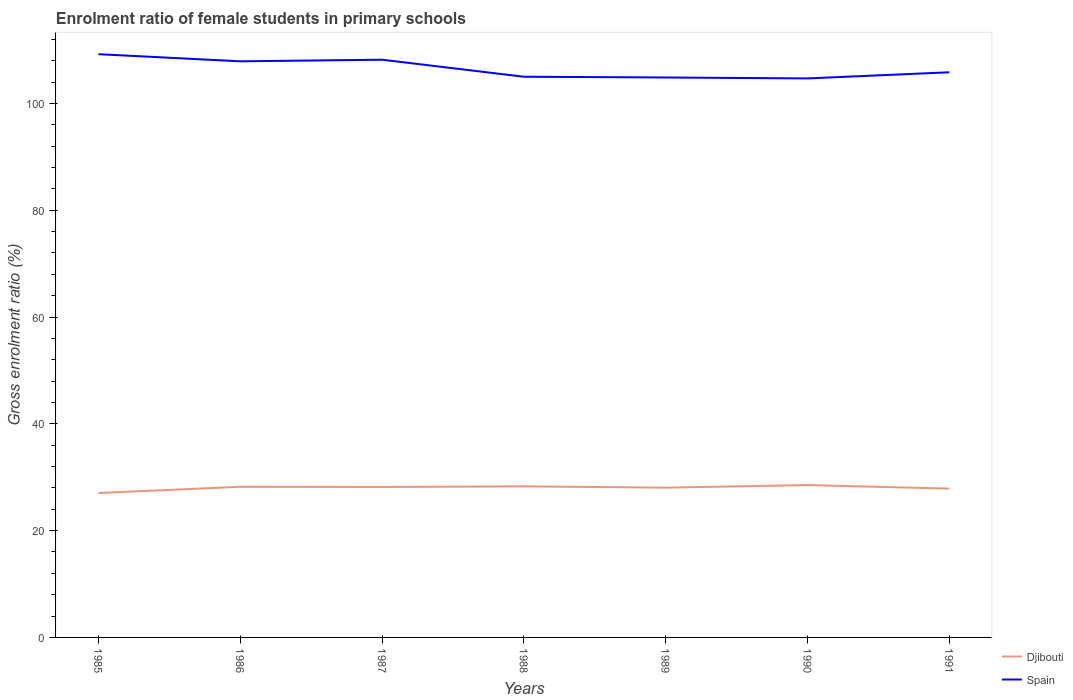How many different coloured lines are there?
Provide a succinct answer. 2. Does the line corresponding to Djibouti intersect with the line corresponding to Spain?
Your response must be concise. No. Across all years, what is the maximum enrolment ratio of female students in primary schools in Djibouti?
Make the answer very short. 27.05. What is the total enrolment ratio of female students in primary schools in Djibouti in the graph?
Your response must be concise. 0.16. What is the difference between the highest and the second highest enrolment ratio of female students in primary schools in Spain?
Ensure brevity in your answer.  4.54. What is the difference between two consecutive major ticks on the Y-axis?
Your answer should be compact. 20. How many legend labels are there?
Provide a short and direct response. 2. What is the title of the graph?
Your answer should be very brief. Enrolment ratio of female students in primary schools. Does "San Marino" appear as one of the legend labels in the graph?
Your answer should be compact. No. What is the label or title of the Y-axis?
Keep it short and to the point. Gross enrolment ratio (%). What is the Gross enrolment ratio (%) of Djibouti in 1985?
Ensure brevity in your answer.  27.05. What is the Gross enrolment ratio (%) in Spain in 1985?
Your answer should be very brief. 109.23. What is the Gross enrolment ratio (%) in Djibouti in 1986?
Make the answer very short. 28.21. What is the Gross enrolment ratio (%) in Spain in 1986?
Offer a terse response. 107.89. What is the Gross enrolment ratio (%) of Djibouti in 1987?
Give a very brief answer. 28.18. What is the Gross enrolment ratio (%) in Spain in 1987?
Offer a very short reply. 108.19. What is the Gross enrolment ratio (%) in Djibouti in 1988?
Provide a short and direct response. 28.3. What is the Gross enrolment ratio (%) in Spain in 1988?
Your response must be concise. 105. What is the Gross enrolment ratio (%) of Djibouti in 1989?
Make the answer very short. 28.05. What is the Gross enrolment ratio (%) in Spain in 1989?
Your response must be concise. 104.86. What is the Gross enrolment ratio (%) in Djibouti in 1990?
Your response must be concise. 28.54. What is the Gross enrolment ratio (%) of Spain in 1990?
Offer a very short reply. 104.69. What is the Gross enrolment ratio (%) in Djibouti in 1991?
Your response must be concise. 27.87. What is the Gross enrolment ratio (%) in Spain in 1991?
Your response must be concise. 105.84. Across all years, what is the maximum Gross enrolment ratio (%) in Djibouti?
Provide a short and direct response. 28.54. Across all years, what is the maximum Gross enrolment ratio (%) in Spain?
Make the answer very short. 109.23. Across all years, what is the minimum Gross enrolment ratio (%) of Djibouti?
Your answer should be compact. 27.05. Across all years, what is the minimum Gross enrolment ratio (%) of Spain?
Provide a succinct answer. 104.69. What is the total Gross enrolment ratio (%) of Djibouti in the graph?
Offer a terse response. 196.19. What is the total Gross enrolment ratio (%) of Spain in the graph?
Make the answer very short. 745.7. What is the difference between the Gross enrolment ratio (%) in Djibouti in 1985 and that in 1986?
Offer a very short reply. -1.16. What is the difference between the Gross enrolment ratio (%) in Spain in 1985 and that in 1986?
Your response must be concise. 1.33. What is the difference between the Gross enrolment ratio (%) in Djibouti in 1985 and that in 1987?
Offer a very short reply. -1.13. What is the difference between the Gross enrolment ratio (%) in Spain in 1985 and that in 1987?
Offer a terse response. 1.03. What is the difference between the Gross enrolment ratio (%) of Djibouti in 1985 and that in 1988?
Keep it short and to the point. -1.25. What is the difference between the Gross enrolment ratio (%) in Spain in 1985 and that in 1988?
Make the answer very short. 4.22. What is the difference between the Gross enrolment ratio (%) of Djibouti in 1985 and that in 1989?
Keep it short and to the point. -1. What is the difference between the Gross enrolment ratio (%) in Spain in 1985 and that in 1989?
Provide a short and direct response. 4.36. What is the difference between the Gross enrolment ratio (%) of Djibouti in 1985 and that in 1990?
Provide a succinct answer. -1.49. What is the difference between the Gross enrolment ratio (%) of Spain in 1985 and that in 1990?
Give a very brief answer. 4.54. What is the difference between the Gross enrolment ratio (%) in Djibouti in 1985 and that in 1991?
Give a very brief answer. -0.82. What is the difference between the Gross enrolment ratio (%) of Spain in 1985 and that in 1991?
Offer a very short reply. 3.39. What is the difference between the Gross enrolment ratio (%) in Djibouti in 1986 and that in 1987?
Your answer should be compact. 0.03. What is the difference between the Gross enrolment ratio (%) in Spain in 1986 and that in 1987?
Offer a terse response. -0.3. What is the difference between the Gross enrolment ratio (%) in Djibouti in 1986 and that in 1988?
Your answer should be very brief. -0.09. What is the difference between the Gross enrolment ratio (%) of Spain in 1986 and that in 1988?
Make the answer very short. 2.89. What is the difference between the Gross enrolment ratio (%) of Djibouti in 1986 and that in 1989?
Give a very brief answer. 0.16. What is the difference between the Gross enrolment ratio (%) of Spain in 1986 and that in 1989?
Your answer should be very brief. 3.03. What is the difference between the Gross enrolment ratio (%) of Djibouti in 1986 and that in 1990?
Keep it short and to the point. -0.33. What is the difference between the Gross enrolment ratio (%) in Spain in 1986 and that in 1990?
Your answer should be compact. 3.2. What is the difference between the Gross enrolment ratio (%) in Djibouti in 1986 and that in 1991?
Ensure brevity in your answer.  0.34. What is the difference between the Gross enrolment ratio (%) in Spain in 1986 and that in 1991?
Give a very brief answer. 2.05. What is the difference between the Gross enrolment ratio (%) of Djibouti in 1987 and that in 1988?
Ensure brevity in your answer.  -0.12. What is the difference between the Gross enrolment ratio (%) in Spain in 1987 and that in 1988?
Your answer should be compact. 3.19. What is the difference between the Gross enrolment ratio (%) of Djibouti in 1987 and that in 1989?
Ensure brevity in your answer.  0.13. What is the difference between the Gross enrolment ratio (%) of Spain in 1987 and that in 1989?
Offer a terse response. 3.33. What is the difference between the Gross enrolment ratio (%) of Djibouti in 1987 and that in 1990?
Your answer should be very brief. -0.36. What is the difference between the Gross enrolment ratio (%) of Spain in 1987 and that in 1990?
Ensure brevity in your answer.  3.51. What is the difference between the Gross enrolment ratio (%) in Djibouti in 1987 and that in 1991?
Keep it short and to the point. 0.31. What is the difference between the Gross enrolment ratio (%) in Spain in 1987 and that in 1991?
Make the answer very short. 2.36. What is the difference between the Gross enrolment ratio (%) in Djibouti in 1988 and that in 1989?
Ensure brevity in your answer.  0.25. What is the difference between the Gross enrolment ratio (%) of Spain in 1988 and that in 1989?
Provide a short and direct response. 0.14. What is the difference between the Gross enrolment ratio (%) of Djibouti in 1988 and that in 1990?
Ensure brevity in your answer.  -0.24. What is the difference between the Gross enrolment ratio (%) in Spain in 1988 and that in 1990?
Give a very brief answer. 0.32. What is the difference between the Gross enrolment ratio (%) in Djibouti in 1988 and that in 1991?
Provide a succinct answer. 0.42. What is the difference between the Gross enrolment ratio (%) in Spain in 1988 and that in 1991?
Your answer should be very brief. -0.84. What is the difference between the Gross enrolment ratio (%) of Djibouti in 1989 and that in 1990?
Ensure brevity in your answer.  -0.49. What is the difference between the Gross enrolment ratio (%) in Spain in 1989 and that in 1990?
Ensure brevity in your answer.  0.18. What is the difference between the Gross enrolment ratio (%) in Djibouti in 1989 and that in 1991?
Keep it short and to the point. 0.18. What is the difference between the Gross enrolment ratio (%) in Spain in 1989 and that in 1991?
Ensure brevity in your answer.  -0.98. What is the difference between the Gross enrolment ratio (%) of Djibouti in 1990 and that in 1991?
Make the answer very short. 0.66. What is the difference between the Gross enrolment ratio (%) in Spain in 1990 and that in 1991?
Your response must be concise. -1.15. What is the difference between the Gross enrolment ratio (%) of Djibouti in 1985 and the Gross enrolment ratio (%) of Spain in 1986?
Give a very brief answer. -80.84. What is the difference between the Gross enrolment ratio (%) in Djibouti in 1985 and the Gross enrolment ratio (%) in Spain in 1987?
Offer a very short reply. -81.15. What is the difference between the Gross enrolment ratio (%) in Djibouti in 1985 and the Gross enrolment ratio (%) in Spain in 1988?
Provide a short and direct response. -77.96. What is the difference between the Gross enrolment ratio (%) of Djibouti in 1985 and the Gross enrolment ratio (%) of Spain in 1989?
Your answer should be very brief. -77.81. What is the difference between the Gross enrolment ratio (%) in Djibouti in 1985 and the Gross enrolment ratio (%) in Spain in 1990?
Ensure brevity in your answer.  -77.64. What is the difference between the Gross enrolment ratio (%) in Djibouti in 1985 and the Gross enrolment ratio (%) in Spain in 1991?
Give a very brief answer. -78.79. What is the difference between the Gross enrolment ratio (%) of Djibouti in 1986 and the Gross enrolment ratio (%) of Spain in 1987?
Your answer should be compact. -79.98. What is the difference between the Gross enrolment ratio (%) in Djibouti in 1986 and the Gross enrolment ratio (%) in Spain in 1988?
Offer a terse response. -76.79. What is the difference between the Gross enrolment ratio (%) in Djibouti in 1986 and the Gross enrolment ratio (%) in Spain in 1989?
Your answer should be very brief. -76.65. What is the difference between the Gross enrolment ratio (%) of Djibouti in 1986 and the Gross enrolment ratio (%) of Spain in 1990?
Make the answer very short. -76.48. What is the difference between the Gross enrolment ratio (%) in Djibouti in 1986 and the Gross enrolment ratio (%) in Spain in 1991?
Your answer should be very brief. -77.63. What is the difference between the Gross enrolment ratio (%) of Djibouti in 1987 and the Gross enrolment ratio (%) of Spain in 1988?
Your answer should be compact. -76.83. What is the difference between the Gross enrolment ratio (%) of Djibouti in 1987 and the Gross enrolment ratio (%) of Spain in 1989?
Make the answer very short. -76.69. What is the difference between the Gross enrolment ratio (%) in Djibouti in 1987 and the Gross enrolment ratio (%) in Spain in 1990?
Your answer should be very brief. -76.51. What is the difference between the Gross enrolment ratio (%) of Djibouti in 1987 and the Gross enrolment ratio (%) of Spain in 1991?
Give a very brief answer. -77.66. What is the difference between the Gross enrolment ratio (%) of Djibouti in 1988 and the Gross enrolment ratio (%) of Spain in 1989?
Your answer should be very brief. -76.57. What is the difference between the Gross enrolment ratio (%) in Djibouti in 1988 and the Gross enrolment ratio (%) in Spain in 1990?
Your answer should be very brief. -76.39. What is the difference between the Gross enrolment ratio (%) in Djibouti in 1988 and the Gross enrolment ratio (%) in Spain in 1991?
Your answer should be very brief. -77.54. What is the difference between the Gross enrolment ratio (%) in Djibouti in 1989 and the Gross enrolment ratio (%) in Spain in 1990?
Provide a succinct answer. -76.64. What is the difference between the Gross enrolment ratio (%) of Djibouti in 1989 and the Gross enrolment ratio (%) of Spain in 1991?
Give a very brief answer. -77.79. What is the difference between the Gross enrolment ratio (%) in Djibouti in 1990 and the Gross enrolment ratio (%) in Spain in 1991?
Keep it short and to the point. -77.3. What is the average Gross enrolment ratio (%) in Djibouti per year?
Give a very brief answer. 28.03. What is the average Gross enrolment ratio (%) of Spain per year?
Your answer should be very brief. 106.53. In the year 1985, what is the difference between the Gross enrolment ratio (%) of Djibouti and Gross enrolment ratio (%) of Spain?
Ensure brevity in your answer.  -82.18. In the year 1986, what is the difference between the Gross enrolment ratio (%) of Djibouti and Gross enrolment ratio (%) of Spain?
Your response must be concise. -79.68. In the year 1987, what is the difference between the Gross enrolment ratio (%) in Djibouti and Gross enrolment ratio (%) in Spain?
Keep it short and to the point. -80.02. In the year 1988, what is the difference between the Gross enrolment ratio (%) of Djibouti and Gross enrolment ratio (%) of Spain?
Your answer should be very brief. -76.71. In the year 1989, what is the difference between the Gross enrolment ratio (%) in Djibouti and Gross enrolment ratio (%) in Spain?
Provide a succinct answer. -76.81. In the year 1990, what is the difference between the Gross enrolment ratio (%) in Djibouti and Gross enrolment ratio (%) in Spain?
Your answer should be compact. -76.15. In the year 1991, what is the difference between the Gross enrolment ratio (%) of Djibouti and Gross enrolment ratio (%) of Spain?
Provide a short and direct response. -77.97. What is the ratio of the Gross enrolment ratio (%) in Djibouti in 1985 to that in 1986?
Ensure brevity in your answer.  0.96. What is the ratio of the Gross enrolment ratio (%) of Spain in 1985 to that in 1986?
Provide a succinct answer. 1.01. What is the ratio of the Gross enrolment ratio (%) in Spain in 1985 to that in 1987?
Offer a terse response. 1.01. What is the ratio of the Gross enrolment ratio (%) of Djibouti in 1985 to that in 1988?
Keep it short and to the point. 0.96. What is the ratio of the Gross enrolment ratio (%) in Spain in 1985 to that in 1988?
Ensure brevity in your answer.  1.04. What is the ratio of the Gross enrolment ratio (%) in Spain in 1985 to that in 1989?
Your answer should be very brief. 1.04. What is the ratio of the Gross enrolment ratio (%) in Djibouti in 1985 to that in 1990?
Ensure brevity in your answer.  0.95. What is the ratio of the Gross enrolment ratio (%) of Spain in 1985 to that in 1990?
Provide a short and direct response. 1.04. What is the ratio of the Gross enrolment ratio (%) of Djibouti in 1985 to that in 1991?
Your answer should be compact. 0.97. What is the ratio of the Gross enrolment ratio (%) of Spain in 1985 to that in 1991?
Give a very brief answer. 1.03. What is the ratio of the Gross enrolment ratio (%) in Djibouti in 1986 to that in 1987?
Provide a short and direct response. 1. What is the ratio of the Gross enrolment ratio (%) in Spain in 1986 to that in 1987?
Your answer should be very brief. 1. What is the ratio of the Gross enrolment ratio (%) in Spain in 1986 to that in 1988?
Keep it short and to the point. 1.03. What is the ratio of the Gross enrolment ratio (%) in Djibouti in 1986 to that in 1989?
Provide a succinct answer. 1.01. What is the ratio of the Gross enrolment ratio (%) of Spain in 1986 to that in 1989?
Offer a very short reply. 1.03. What is the ratio of the Gross enrolment ratio (%) of Djibouti in 1986 to that in 1990?
Your answer should be compact. 0.99. What is the ratio of the Gross enrolment ratio (%) in Spain in 1986 to that in 1990?
Your answer should be very brief. 1.03. What is the ratio of the Gross enrolment ratio (%) in Djibouti in 1986 to that in 1991?
Offer a terse response. 1.01. What is the ratio of the Gross enrolment ratio (%) in Spain in 1986 to that in 1991?
Keep it short and to the point. 1.02. What is the ratio of the Gross enrolment ratio (%) in Djibouti in 1987 to that in 1988?
Offer a very short reply. 1. What is the ratio of the Gross enrolment ratio (%) in Spain in 1987 to that in 1988?
Provide a succinct answer. 1.03. What is the ratio of the Gross enrolment ratio (%) in Spain in 1987 to that in 1989?
Keep it short and to the point. 1.03. What is the ratio of the Gross enrolment ratio (%) in Djibouti in 1987 to that in 1990?
Give a very brief answer. 0.99. What is the ratio of the Gross enrolment ratio (%) in Spain in 1987 to that in 1990?
Give a very brief answer. 1.03. What is the ratio of the Gross enrolment ratio (%) in Spain in 1987 to that in 1991?
Your response must be concise. 1.02. What is the ratio of the Gross enrolment ratio (%) of Djibouti in 1988 to that in 1989?
Your response must be concise. 1.01. What is the ratio of the Gross enrolment ratio (%) in Djibouti in 1988 to that in 1990?
Your answer should be compact. 0.99. What is the ratio of the Gross enrolment ratio (%) in Spain in 1988 to that in 1990?
Give a very brief answer. 1. What is the ratio of the Gross enrolment ratio (%) of Djibouti in 1988 to that in 1991?
Your answer should be compact. 1.02. What is the ratio of the Gross enrolment ratio (%) in Spain in 1989 to that in 1990?
Your response must be concise. 1. What is the ratio of the Gross enrolment ratio (%) of Djibouti in 1989 to that in 1991?
Keep it short and to the point. 1.01. What is the ratio of the Gross enrolment ratio (%) of Spain in 1989 to that in 1991?
Your response must be concise. 0.99. What is the ratio of the Gross enrolment ratio (%) in Djibouti in 1990 to that in 1991?
Your answer should be very brief. 1.02. What is the ratio of the Gross enrolment ratio (%) in Spain in 1990 to that in 1991?
Ensure brevity in your answer.  0.99. What is the difference between the highest and the second highest Gross enrolment ratio (%) in Djibouti?
Your response must be concise. 0.24. What is the difference between the highest and the second highest Gross enrolment ratio (%) of Spain?
Offer a terse response. 1.03. What is the difference between the highest and the lowest Gross enrolment ratio (%) of Djibouti?
Provide a succinct answer. 1.49. What is the difference between the highest and the lowest Gross enrolment ratio (%) of Spain?
Provide a succinct answer. 4.54. 